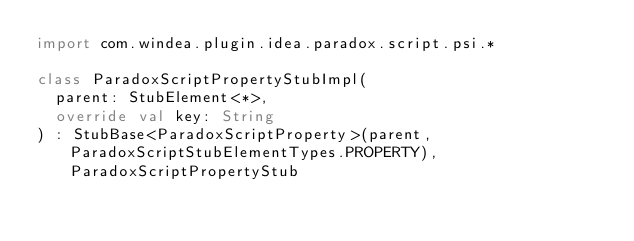Convert code to text. <code><loc_0><loc_0><loc_500><loc_500><_Kotlin_>import com.windea.plugin.idea.paradox.script.psi.*

class ParadoxScriptPropertyStubImpl(
	parent: StubElement<*>,
	override val key: String
) : StubBase<ParadoxScriptProperty>(parent, ParadoxScriptStubElementTypes.PROPERTY), ParadoxScriptPropertyStub

</code> 